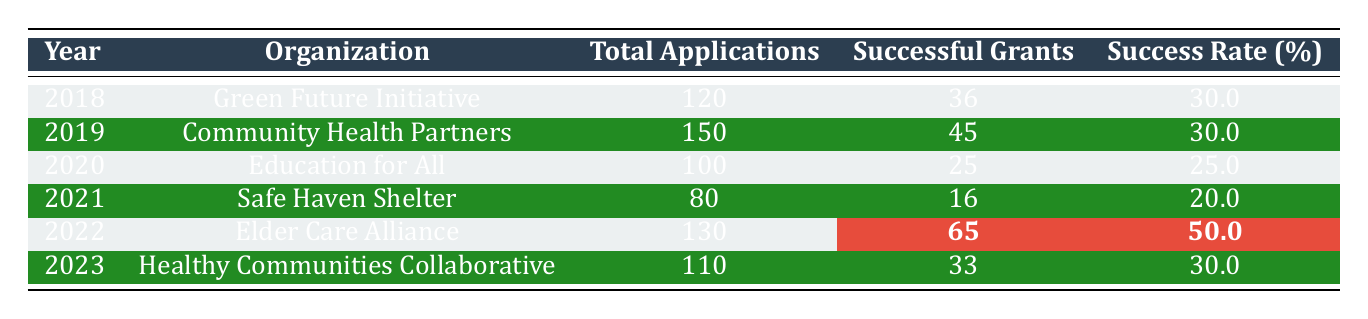What is the success rate for the Elder Care Alliance in 2022? The success rate for the Elder Care Alliance in 2022 is highlighted in the table, which indicates it is 50.0%.
Answer: 50.0 How many total applications were submitted by Community Health Partners in 2019? The total applications submitted by Community Health Partners in 2019 are listed in the table, which shows 150 total applications.
Answer: 150 Was the success rate for Safe Haven Shelter in 2021 higher than 25%? The success rate for Safe Haven Shelter in 2021 is 20.0%, which is lower than 25%.
Answer: No How many successful grants did Education for All have compared to the total applications in 2020? Education for All had 25 successful grants out of 100 total applications in 2020. This can be calculated as a ratio of successful grants to total applications (25/100).
Answer: 25 successful grants In what year did the organization with the highest success rate operate? The highest success rate of 50.0% occurred in 2022 with the Elder Care Alliance.
Answer: 2022 What is the average success rate for the years provided in the table? The success rates for the years are: 30.0, 30.0, 25.0, 20.0, 50.0, and 30.0. Adding these gives a sum of 185. There are 6 years, so the average is 185/6 = 30.83.
Answer: 30.83 Which organization had the lowest number of successful grants and what is the success rate? Safe Haven Shelter had the lowest number of successful grants at 16, with a success rate of 20.0%.
Answer: 16 successful grants and 20.0% success rate How many more total applications were submitted in 2019 than in 2020? In 2019, there were 150 total applications, and in 2020 there were 100. The difference in applications is 150 - 100 = 50.
Answer: 50 more applications Did any organization have a success rate below 30.0% in the years listed? Yes, both Education for All in 2020 (25.0%) and Safe Haven Shelter in 2021 (20.0%) had success rates below 30.0%.
Answer: Yes What was the percentage increase in successful grants from 2021 to 2022? In 2021, there were 16 successful grants, and in 2022, there were 65 successful grants. The increase is 65 - 16 = 49. The percentage increase is (49/16) * 100 = 306.25%.
Answer: 306.25% increase 